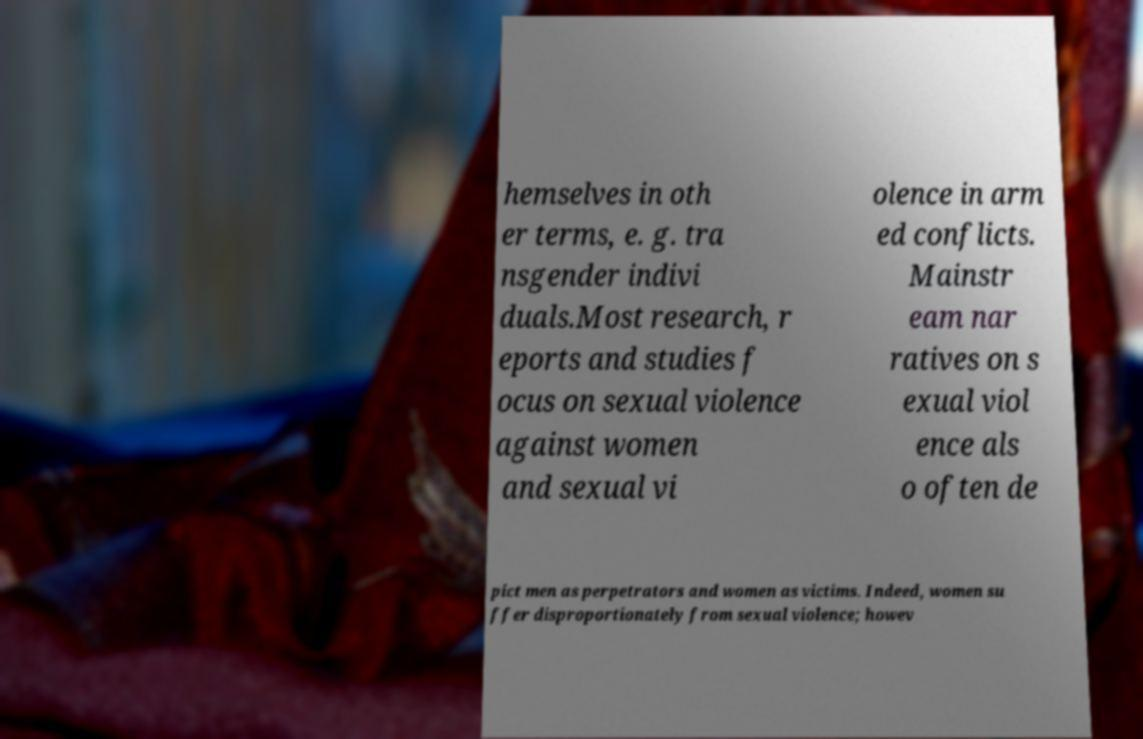Please read and relay the text visible in this image. What does it say? hemselves in oth er terms, e. g. tra nsgender indivi duals.Most research, r eports and studies f ocus on sexual violence against women and sexual vi olence in arm ed conflicts. Mainstr eam nar ratives on s exual viol ence als o often de pict men as perpetrators and women as victims. Indeed, women su ffer disproportionately from sexual violence; howev 